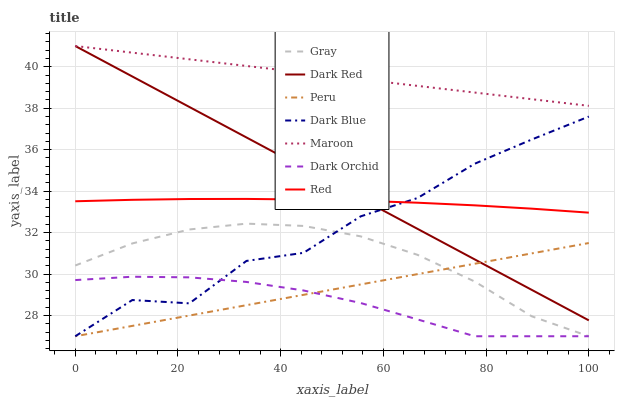Does Dark Orchid have the minimum area under the curve?
Answer yes or no. Yes. Does Maroon have the maximum area under the curve?
Answer yes or no. Yes. Does Dark Red have the minimum area under the curve?
Answer yes or no. No. Does Dark Red have the maximum area under the curve?
Answer yes or no. No. Is Peru the smoothest?
Answer yes or no. Yes. Is Dark Blue the roughest?
Answer yes or no. Yes. Is Dark Red the smoothest?
Answer yes or no. No. Is Dark Red the roughest?
Answer yes or no. No. Does Gray have the lowest value?
Answer yes or no. Yes. Does Dark Red have the lowest value?
Answer yes or no. No. Does Maroon have the highest value?
Answer yes or no. Yes. Does Dark Blue have the highest value?
Answer yes or no. No. Is Dark Orchid less than Red?
Answer yes or no. Yes. Is Dark Red greater than Gray?
Answer yes or no. Yes. Does Dark Red intersect Maroon?
Answer yes or no. Yes. Is Dark Red less than Maroon?
Answer yes or no. No. Is Dark Red greater than Maroon?
Answer yes or no. No. Does Dark Orchid intersect Red?
Answer yes or no. No. 